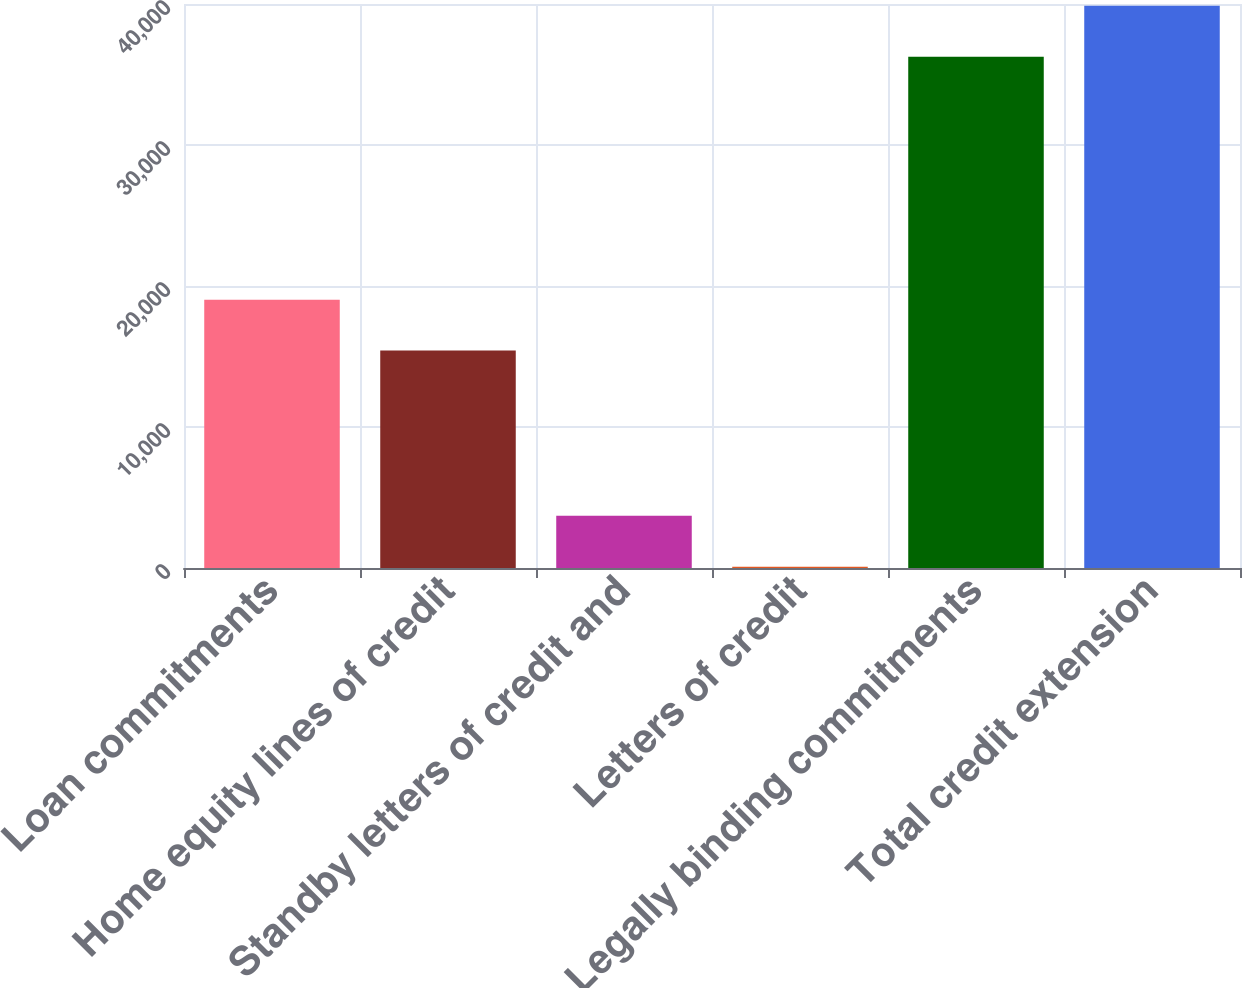<chart> <loc_0><loc_0><loc_500><loc_500><bar_chart><fcel>Loan commitments<fcel>Home equity lines of credit<fcel>Standby letters of credit and<fcel>Letters of credit<fcel>Legally binding commitments<fcel>Total credit extension<nl><fcel>19033.6<fcel>15417<fcel>3704.6<fcel>88<fcel>36254<fcel>39870.6<nl></chart> 